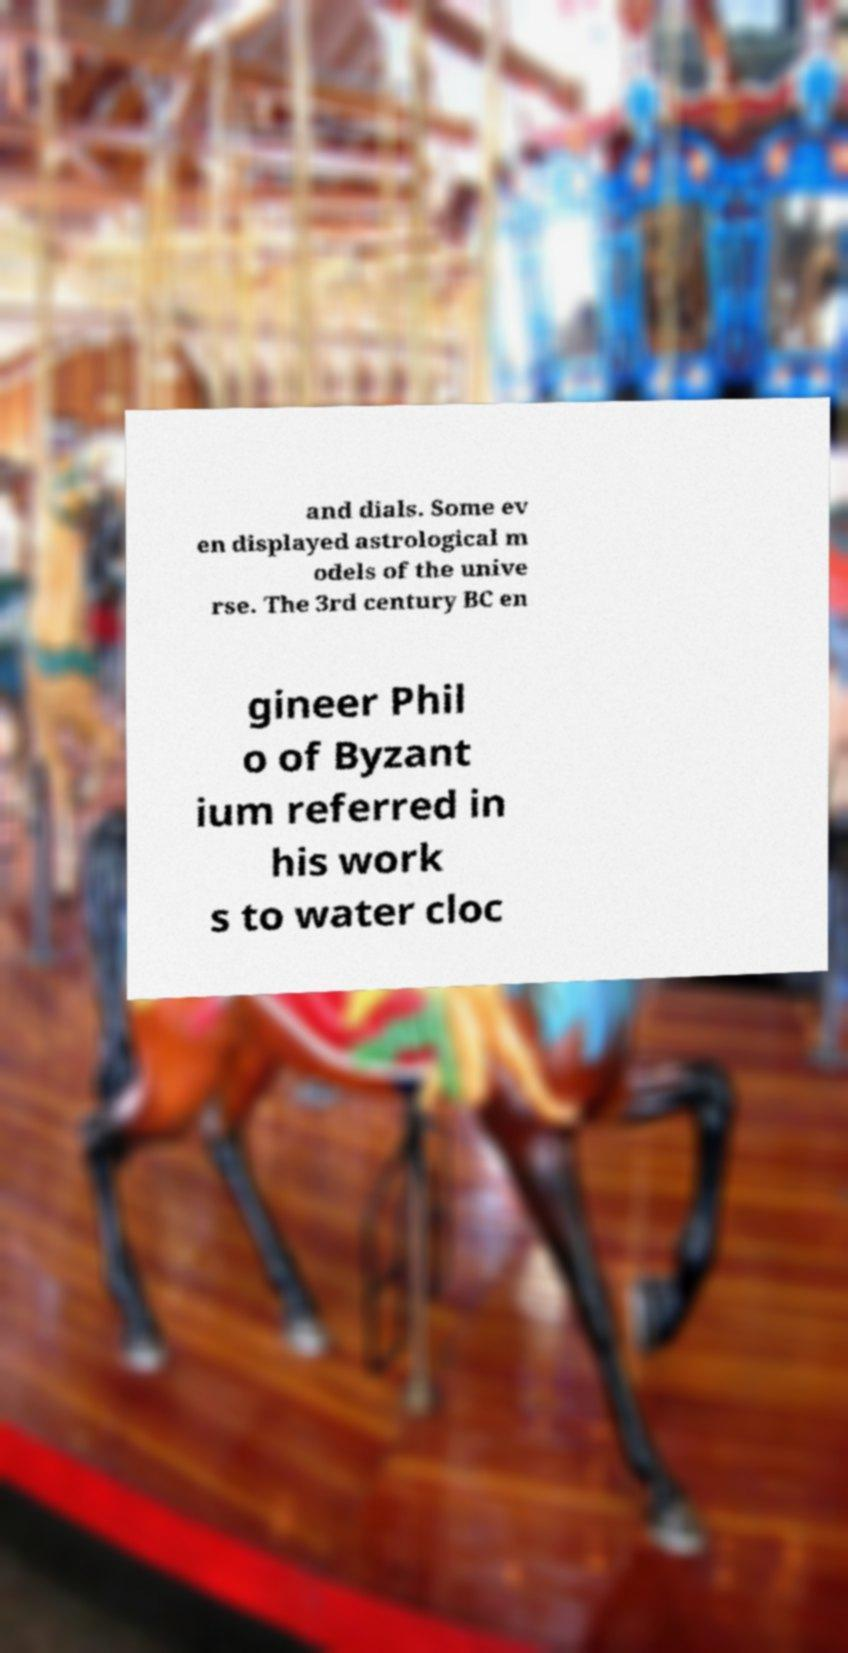Please identify and transcribe the text found in this image. and dials. Some ev en displayed astrological m odels of the unive rse. The 3rd century BC en gineer Phil o of Byzant ium referred in his work s to water cloc 